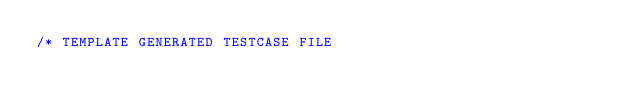<code> <loc_0><loc_0><loc_500><loc_500><_C_>/* TEMPLATE GENERATED TESTCASE FILE</code> 